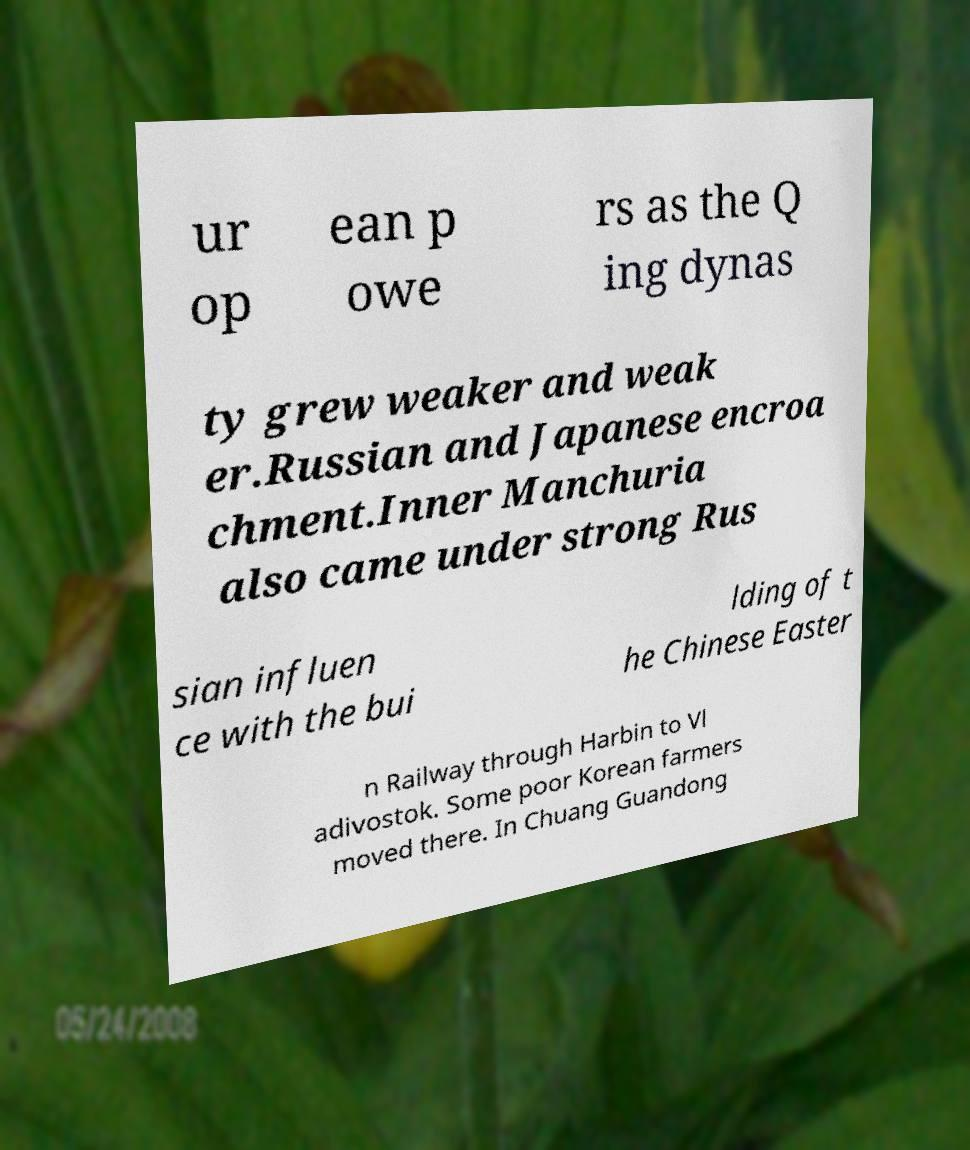What messages or text are displayed in this image? I need them in a readable, typed format. ur op ean p owe rs as the Q ing dynas ty grew weaker and weak er.Russian and Japanese encroa chment.Inner Manchuria also came under strong Rus sian influen ce with the bui lding of t he Chinese Easter n Railway through Harbin to Vl adivostok. Some poor Korean farmers moved there. In Chuang Guandong 